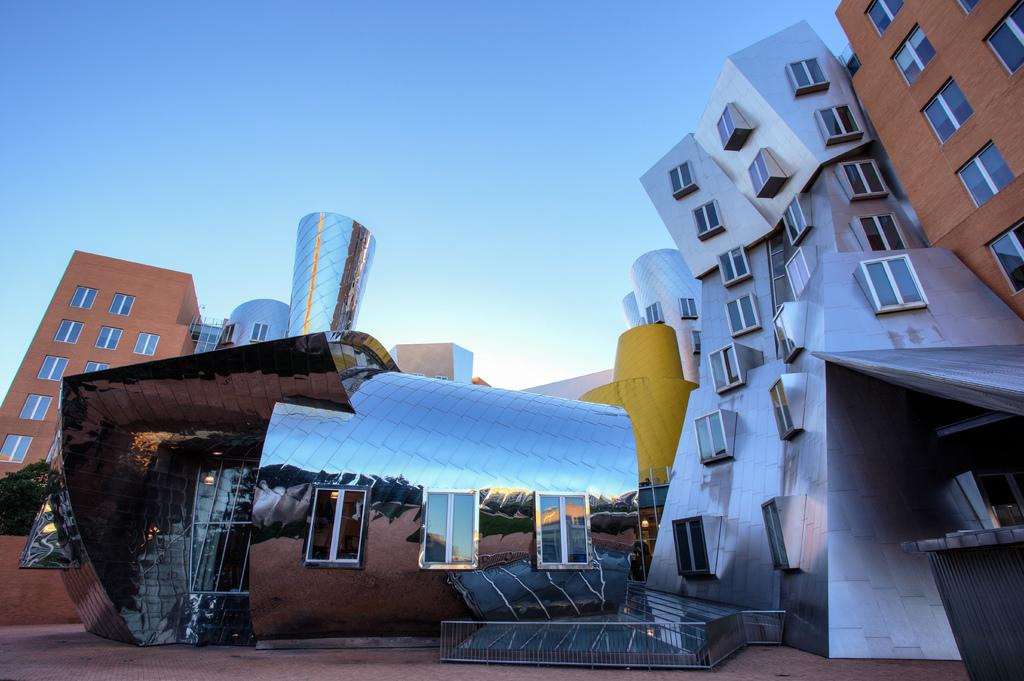What type of structures can be seen in the image? There are many buildings with windows in the image. What can be seen in the background of the image? The sky is visible in the background of the image. Can you describe a specific building in the image? There is a building with glass walls in the image. What is unique about the building with glass walls? There are reflections on the walls of the building with glass walls. What type of pizzas can be seen falling from the sky in the image? There are no pizzas visible in the image, nor are there any falling from the sky. 